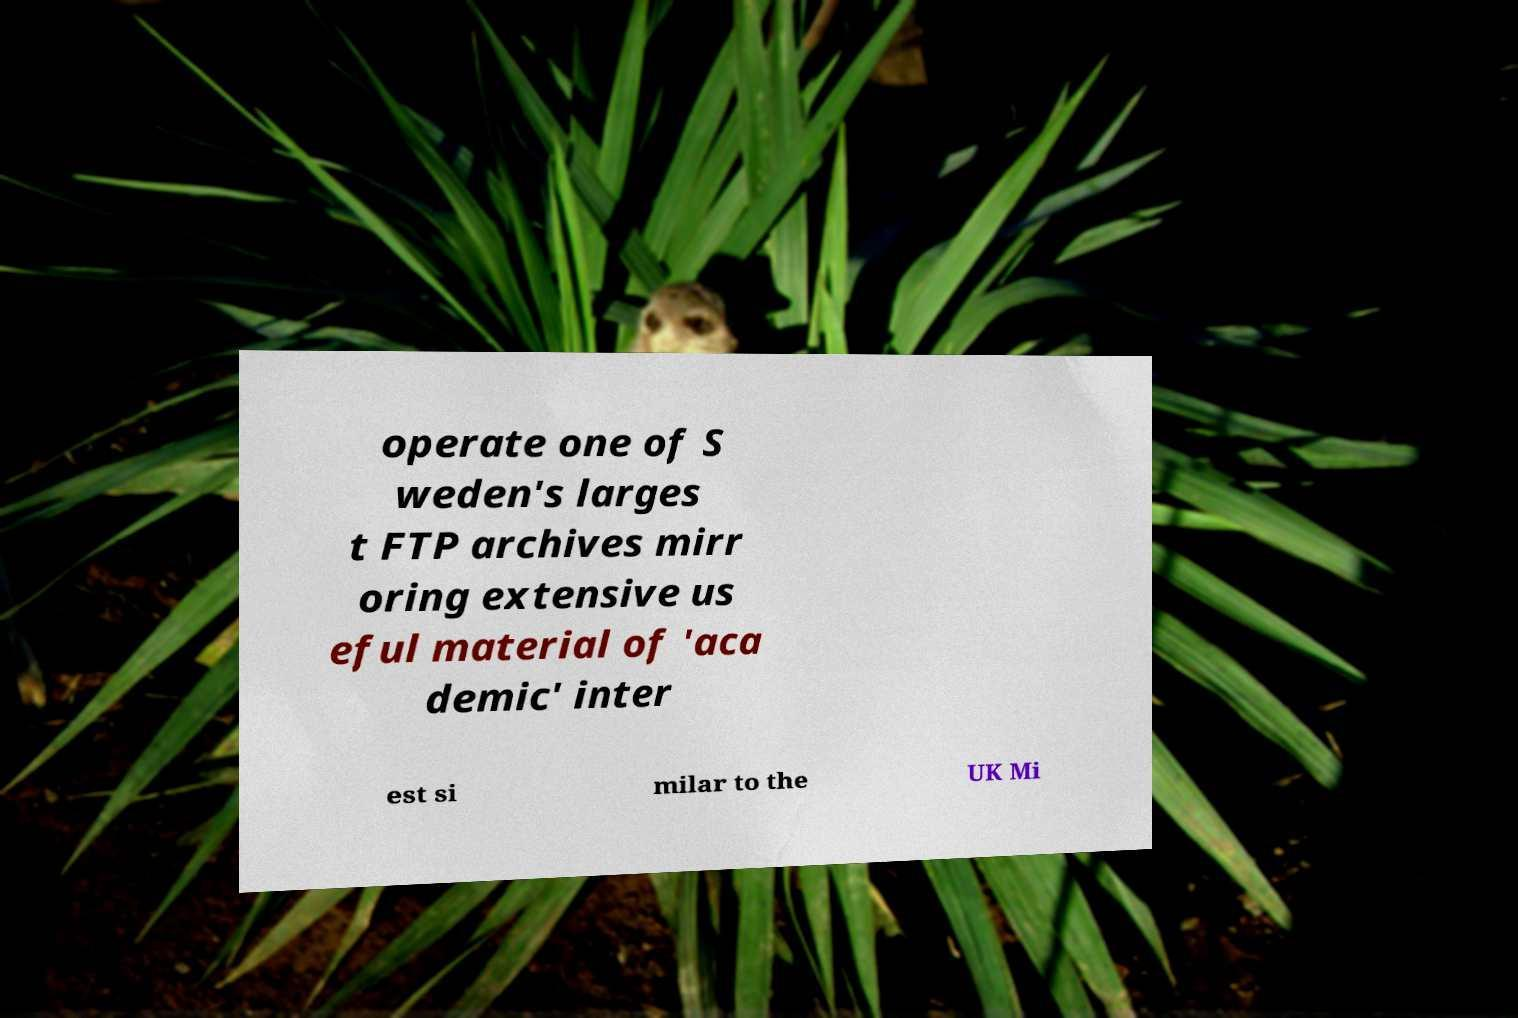I need the written content from this picture converted into text. Can you do that? operate one of S weden's larges t FTP archives mirr oring extensive us eful material of 'aca demic' inter est si milar to the UK Mi 